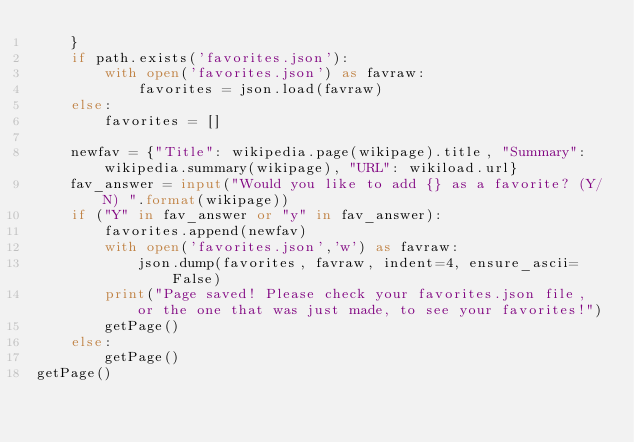Convert code to text. <code><loc_0><loc_0><loc_500><loc_500><_Python_>    }
    if path.exists('favorites.json'):
        with open('favorites.json') as favraw:
            favorites = json.load(favraw)
    else:
        favorites = []

    newfav = {"Title": wikipedia.page(wikipage).title, "Summary": wikipedia.summary(wikipage), "URL": wikiload.url}
    fav_answer = input("Would you like to add {} as a favorite? (Y/N) ".format(wikipage))
    if ("Y" in fav_answer or "y" in fav_answer):
        favorites.append(newfav)
        with open('favorites.json','w') as favraw:
            json.dump(favorites, favraw, indent=4, ensure_ascii=False)
        print("Page saved! Please check your favorites.json file, or the one that was just made, to see your favorites!")
        getPage()
    else:
        getPage()
getPage()</code> 